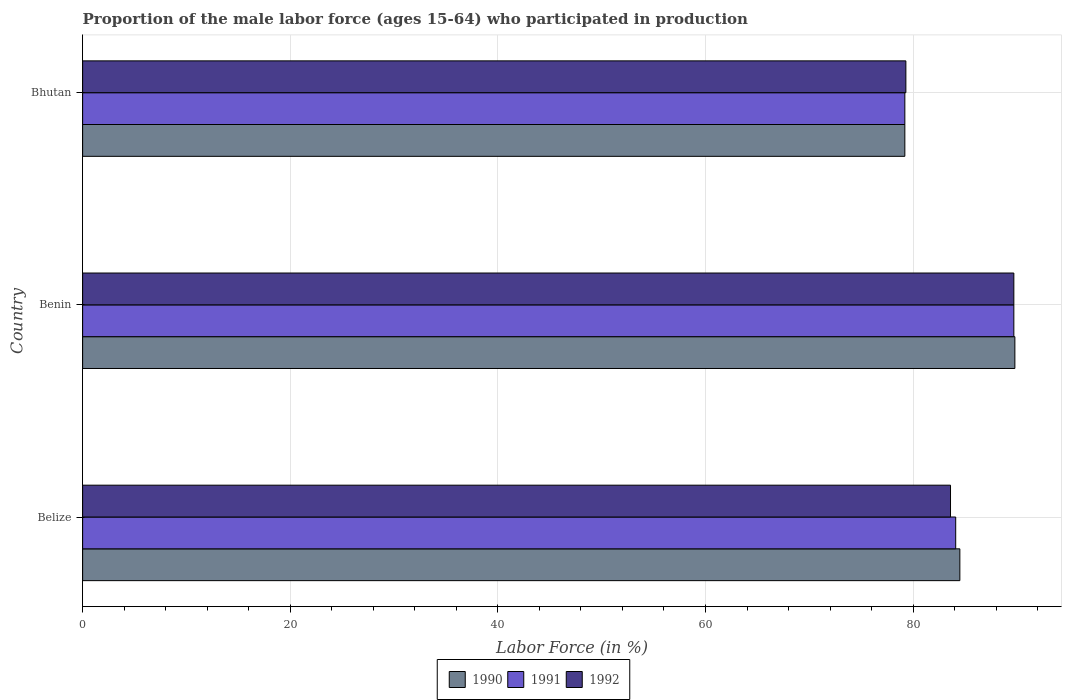How many different coloured bars are there?
Provide a succinct answer. 3. Are the number of bars per tick equal to the number of legend labels?
Your answer should be compact. Yes. How many bars are there on the 3rd tick from the bottom?
Keep it short and to the point. 3. What is the label of the 1st group of bars from the top?
Ensure brevity in your answer.  Bhutan. What is the proportion of the male labor force who participated in production in 1990 in Benin?
Your answer should be very brief. 89.8. Across all countries, what is the maximum proportion of the male labor force who participated in production in 1991?
Provide a short and direct response. 89.7. Across all countries, what is the minimum proportion of the male labor force who participated in production in 1990?
Offer a terse response. 79.2. In which country was the proportion of the male labor force who participated in production in 1992 maximum?
Offer a terse response. Benin. In which country was the proportion of the male labor force who participated in production in 1991 minimum?
Offer a terse response. Bhutan. What is the total proportion of the male labor force who participated in production in 1991 in the graph?
Offer a very short reply. 253. What is the difference between the proportion of the male labor force who participated in production in 1991 in Belize and that in Bhutan?
Your answer should be very brief. 4.9. What is the difference between the proportion of the male labor force who participated in production in 1991 in Belize and the proportion of the male labor force who participated in production in 1990 in Bhutan?
Ensure brevity in your answer.  4.9. What is the average proportion of the male labor force who participated in production in 1991 per country?
Provide a short and direct response. 84.33. What is the difference between the proportion of the male labor force who participated in production in 1990 and proportion of the male labor force who participated in production in 1992 in Benin?
Your response must be concise. 0.1. What is the ratio of the proportion of the male labor force who participated in production in 1990 in Benin to that in Bhutan?
Offer a very short reply. 1.13. Is the proportion of the male labor force who participated in production in 1992 in Belize less than that in Benin?
Provide a short and direct response. Yes. Is the difference between the proportion of the male labor force who participated in production in 1990 in Belize and Benin greater than the difference between the proportion of the male labor force who participated in production in 1992 in Belize and Benin?
Keep it short and to the point. Yes. What is the difference between the highest and the second highest proportion of the male labor force who participated in production in 1990?
Make the answer very short. 5.3. What is the difference between the highest and the lowest proportion of the male labor force who participated in production in 1991?
Make the answer very short. 10.5. In how many countries, is the proportion of the male labor force who participated in production in 1991 greater than the average proportion of the male labor force who participated in production in 1991 taken over all countries?
Make the answer very short. 1. What does the 1st bar from the top in Belize represents?
Your response must be concise. 1992. Are all the bars in the graph horizontal?
Provide a succinct answer. Yes. Where does the legend appear in the graph?
Your response must be concise. Bottom center. How many legend labels are there?
Offer a very short reply. 3. How are the legend labels stacked?
Your answer should be compact. Horizontal. What is the title of the graph?
Provide a succinct answer. Proportion of the male labor force (ages 15-64) who participated in production. Does "1993" appear as one of the legend labels in the graph?
Offer a terse response. No. What is the label or title of the X-axis?
Your answer should be compact. Labor Force (in %). What is the Labor Force (in %) in 1990 in Belize?
Give a very brief answer. 84.5. What is the Labor Force (in %) in 1991 in Belize?
Your answer should be compact. 84.1. What is the Labor Force (in %) in 1992 in Belize?
Your answer should be very brief. 83.6. What is the Labor Force (in %) in 1990 in Benin?
Provide a short and direct response. 89.8. What is the Labor Force (in %) in 1991 in Benin?
Provide a short and direct response. 89.7. What is the Labor Force (in %) in 1992 in Benin?
Offer a terse response. 89.7. What is the Labor Force (in %) of 1990 in Bhutan?
Offer a very short reply. 79.2. What is the Labor Force (in %) in 1991 in Bhutan?
Give a very brief answer. 79.2. What is the Labor Force (in %) in 1992 in Bhutan?
Give a very brief answer. 79.3. Across all countries, what is the maximum Labor Force (in %) in 1990?
Offer a terse response. 89.8. Across all countries, what is the maximum Labor Force (in %) in 1991?
Provide a succinct answer. 89.7. Across all countries, what is the maximum Labor Force (in %) of 1992?
Keep it short and to the point. 89.7. Across all countries, what is the minimum Labor Force (in %) in 1990?
Offer a very short reply. 79.2. Across all countries, what is the minimum Labor Force (in %) in 1991?
Offer a very short reply. 79.2. Across all countries, what is the minimum Labor Force (in %) of 1992?
Your answer should be very brief. 79.3. What is the total Labor Force (in %) in 1990 in the graph?
Keep it short and to the point. 253.5. What is the total Labor Force (in %) of 1991 in the graph?
Give a very brief answer. 253. What is the total Labor Force (in %) of 1992 in the graph?
Give a very brief answer. 252.6. What is the difference between the Labor Force (in %) in 1990 in Belize and that in Benin?
Offer a terse response. -5.3. What is the difference between the Labor Force (in %) in 1992 in Belize and that in Benin?
Offer a very short reply. -6.1. What is the difference between the Labor Force (in %) of 1990 in Belize and that in Bhutan?
Your response must be concise. 5.3. What is the difference between the Labor Force (in %) of 1992 in Belize and that in Bhutan?
Give a very brief answer. 4.3. What is the difference between the Labor Force (in %) in 1990 in Benin and that in Bhutan?
Provide a short and direct response. 10.6. What is the difference between the Labor Force (in %) in 1991 in Benin and that in Bhutan?
Your response must be concise. 10.5. What is the difference between the Labor Force (in %) in 1990 in Belize and the Labor Force (in %) in 1991 in Benin?
Your answer should be very brief. -5.2. What is the difference between the Labor Force (in %) of 1990 in Belize and the Labor Force (in %) of 1992 in Bhutan?
Give a very brief answer. 5.2. What is the difference between the Labor Force (in %) of 1990 in Benin and the Labor Force (in %) of 1991 in Bhutan?
Ensure brevity in your answer.  10.6. What is the difference between the Labor Force (in %) of 1990 in Benin and the Labor Force (in %) of 1992 in Bhutan?
Your answer should be compact. 10.5. What is the difference between the Labor Force (in %) in 1991 in Benin and the Labor Force (in %) in 1992 in Bhutan?
Offer a very short reply. 10.4. What is the average Labor Force (in %) of 1990 per country?
Give a very brief answer. 84.5. What is the average Labor Force (in %) of 1991 per country?
Make the answer very short. 84.33. What is the average Labor Force (in %) in 1992 per country?
Your answer should be compact. 84.2. What is the difference between the Labor Force (in %) of 1991 and Labor Force (in %) of 1992 in Benin?
Provide a succinct answer. 0. What is the difference between the Labor Force (in %) of 1990 and Labor Force (in %) of 1992 in Bhutan?
Ensure brevity in your answer.  -0.1. What is the difference between the Labor Force (in %) of 1991 and Labor Force (in %) of 1992 in Bhutan?
Provide a succinct answer. -0.1. What is the ratio of the Labor Force (in %) in 1990 in Belize to that in Benin?
Provide a short and direct response. 0.94. What is the ratio of the Labor Force (in %) in 1991 in Belize to that in Benin?
Keep it short and to the point. 0.94. What is the ratio of the Labor Force (in %) of 1992 in Belize to that in Benin?
Ensure brevity in your answer.  0.93. What is the ratio of the Labor Force (in %) of 1990 in Belize to that in Bhutan?
Give a very brief answer. 1.07. What is the ratio of the Labor Force (in %) in 1991 in Belize to that in Bhutan?
Your answer should be very brief. 1.06. What is the ratio of the Labor Force (in %) in 1992 in Belize to that in Bhutan?
Your answer should be very brief. 1.05. What is the ratio of the Labor Force (in %) of 1990 in Benin to that in Bhutan?
Your response must be concise. 1.13. What is the ratio of the Labor Force (in %) in 1991 in Benin to that in Bhutan?
Give a very brief answer. 1.13. What is the ratio of the Labor Force (in %) in 1992 in Benin to that in Bhutan?
Provide a short and direct response. 1.13. What is the difference between the highest and the second highest Labor Force (in %) of 1990?
Make the answer very short. 5.3. What is the difference between the highest and the second highest Labor Force (in %) of 1991?
Make the answer very short. 5.6. What is the difference between the highest and the second highest Labor Force (in %) of 1992?
Give a very brief answer. 6.1. What is the difference between the highest and the lowest Labor Force (in %) in 1992?
Offer a very short reply. 10.4. 